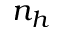Convert formula to latex. <formula><loc_0><loc_0><loc_500><loc_500>n _ { h }</formula> 